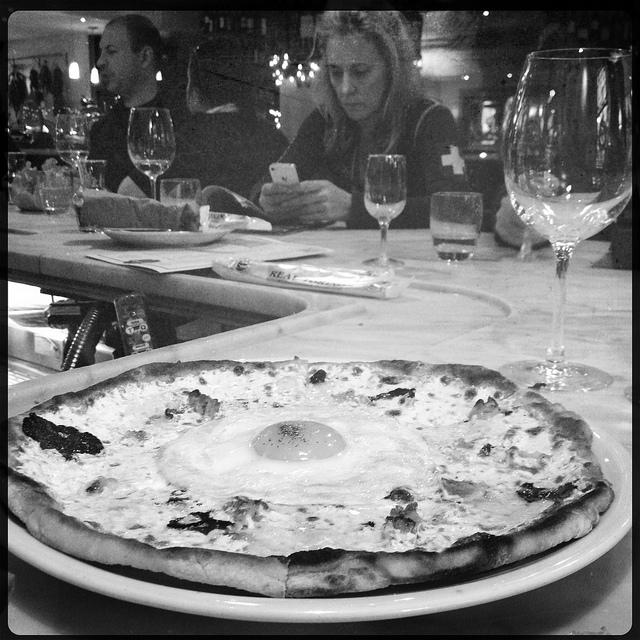Is there anything in the front glass?
Concise answer only. No. Is the egg sunny side up?
Answer briefly. Yes. Is there color in the picture?
Answer briefly. No. 